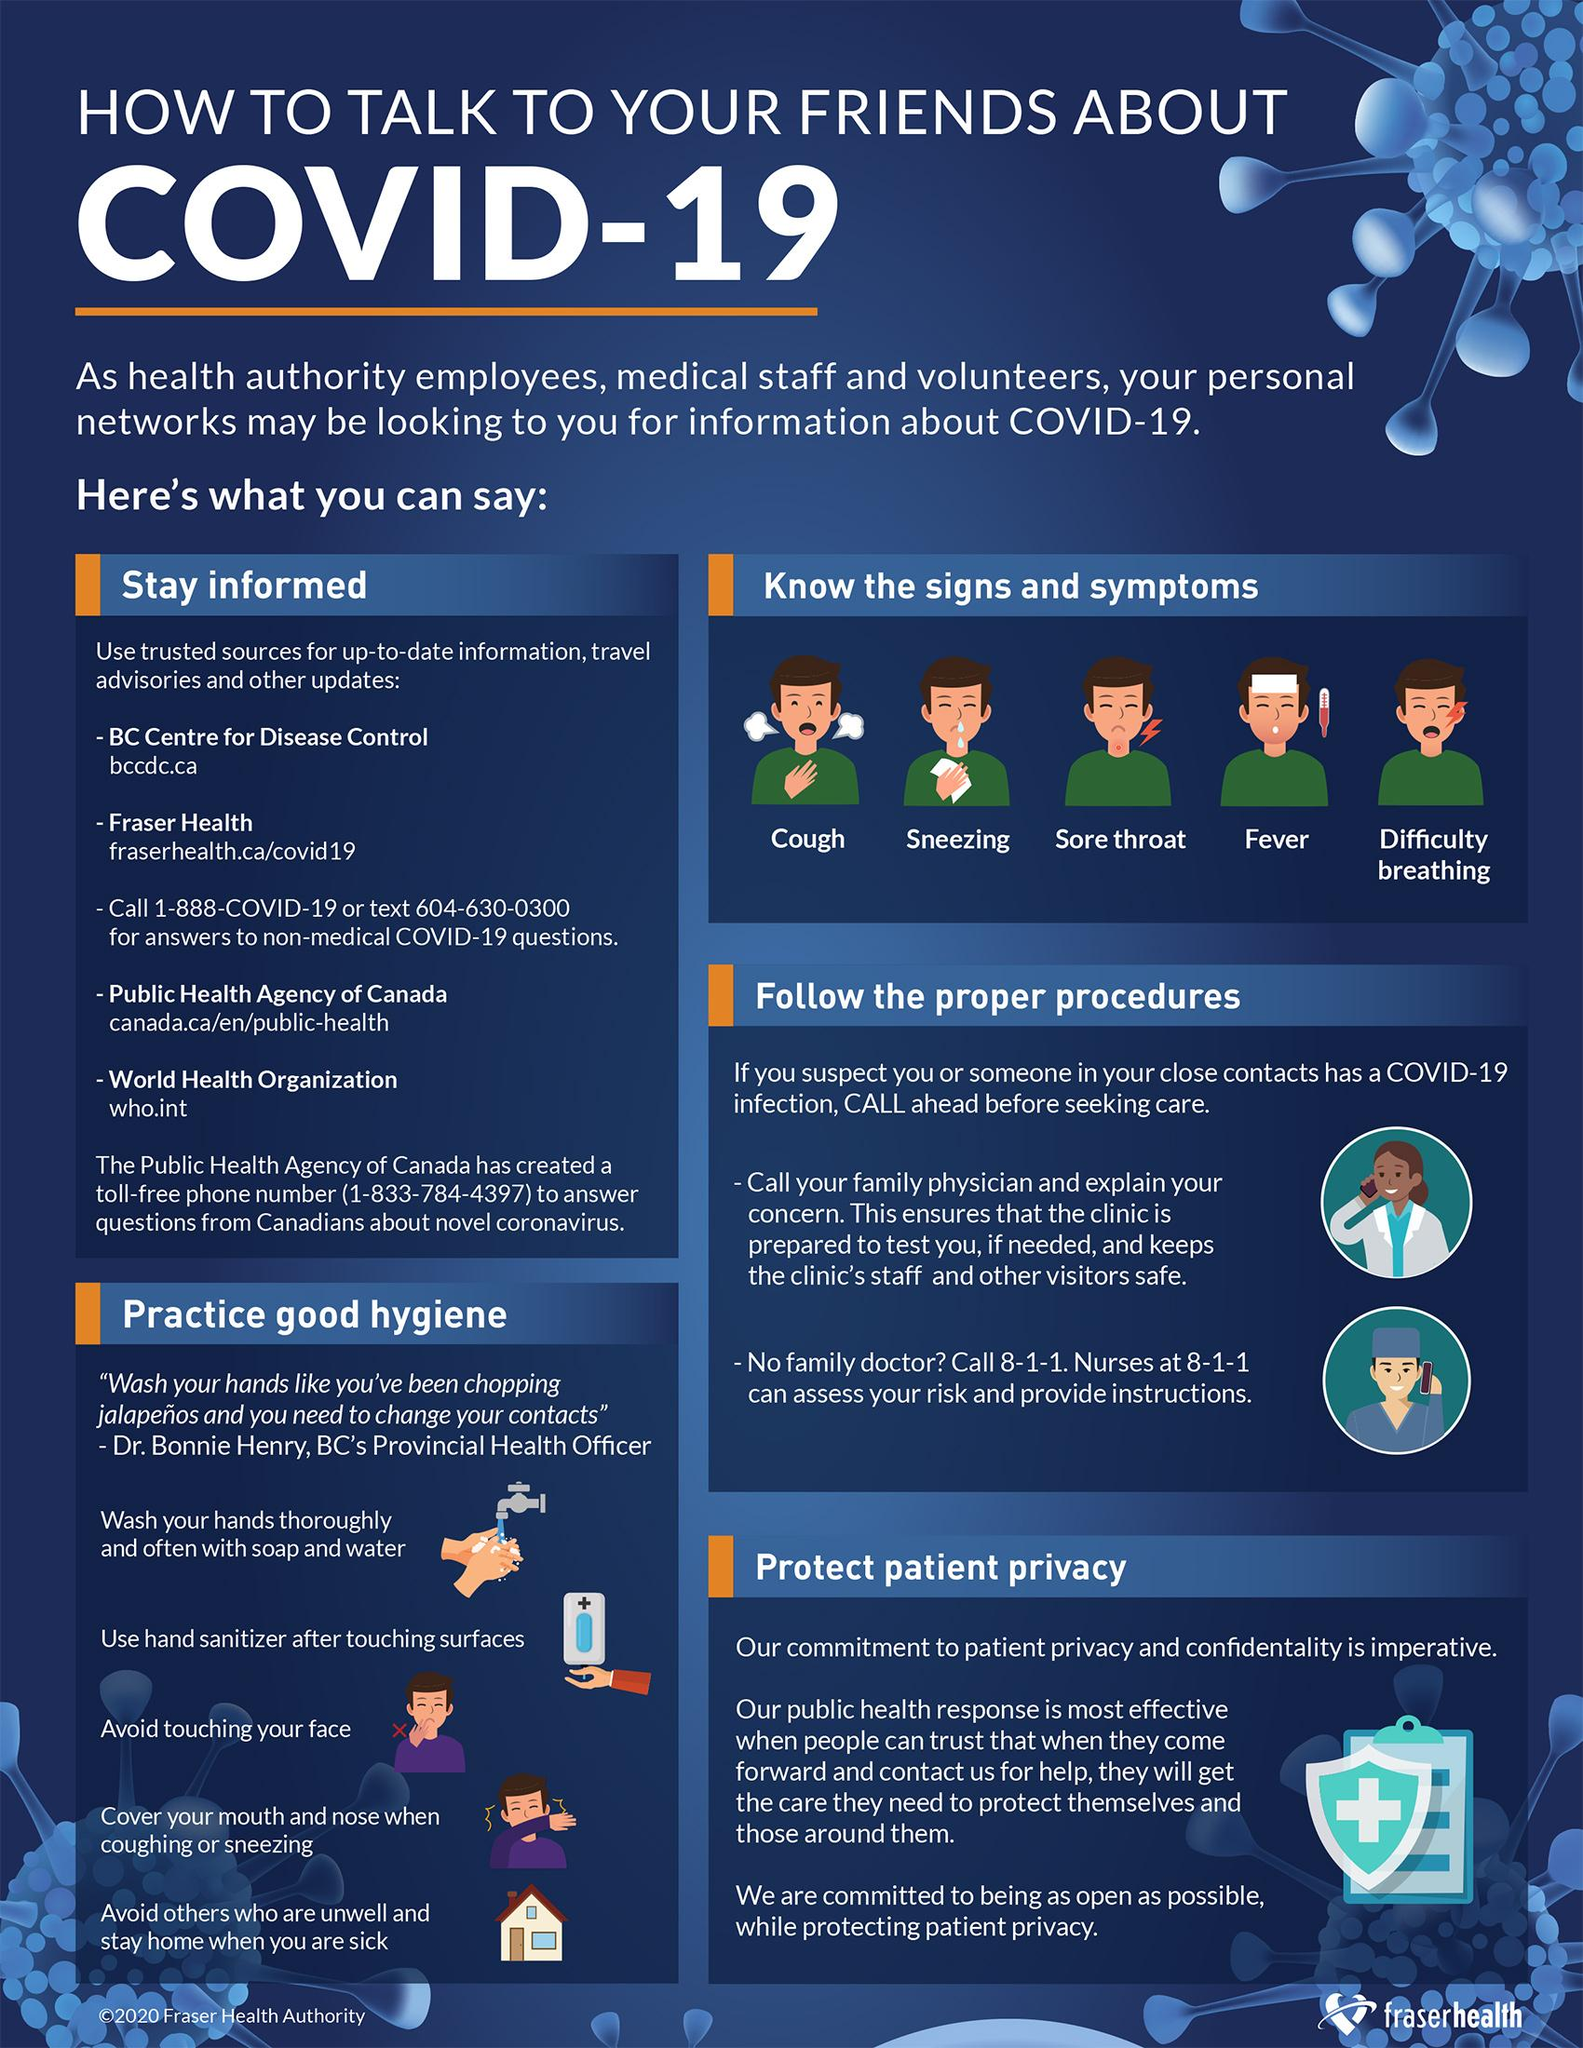Outline some significant characteristics in this image. Other symptoms of COVID-19 besides cough, fever, and difficulty breathing include sneezing and a sore throat. 